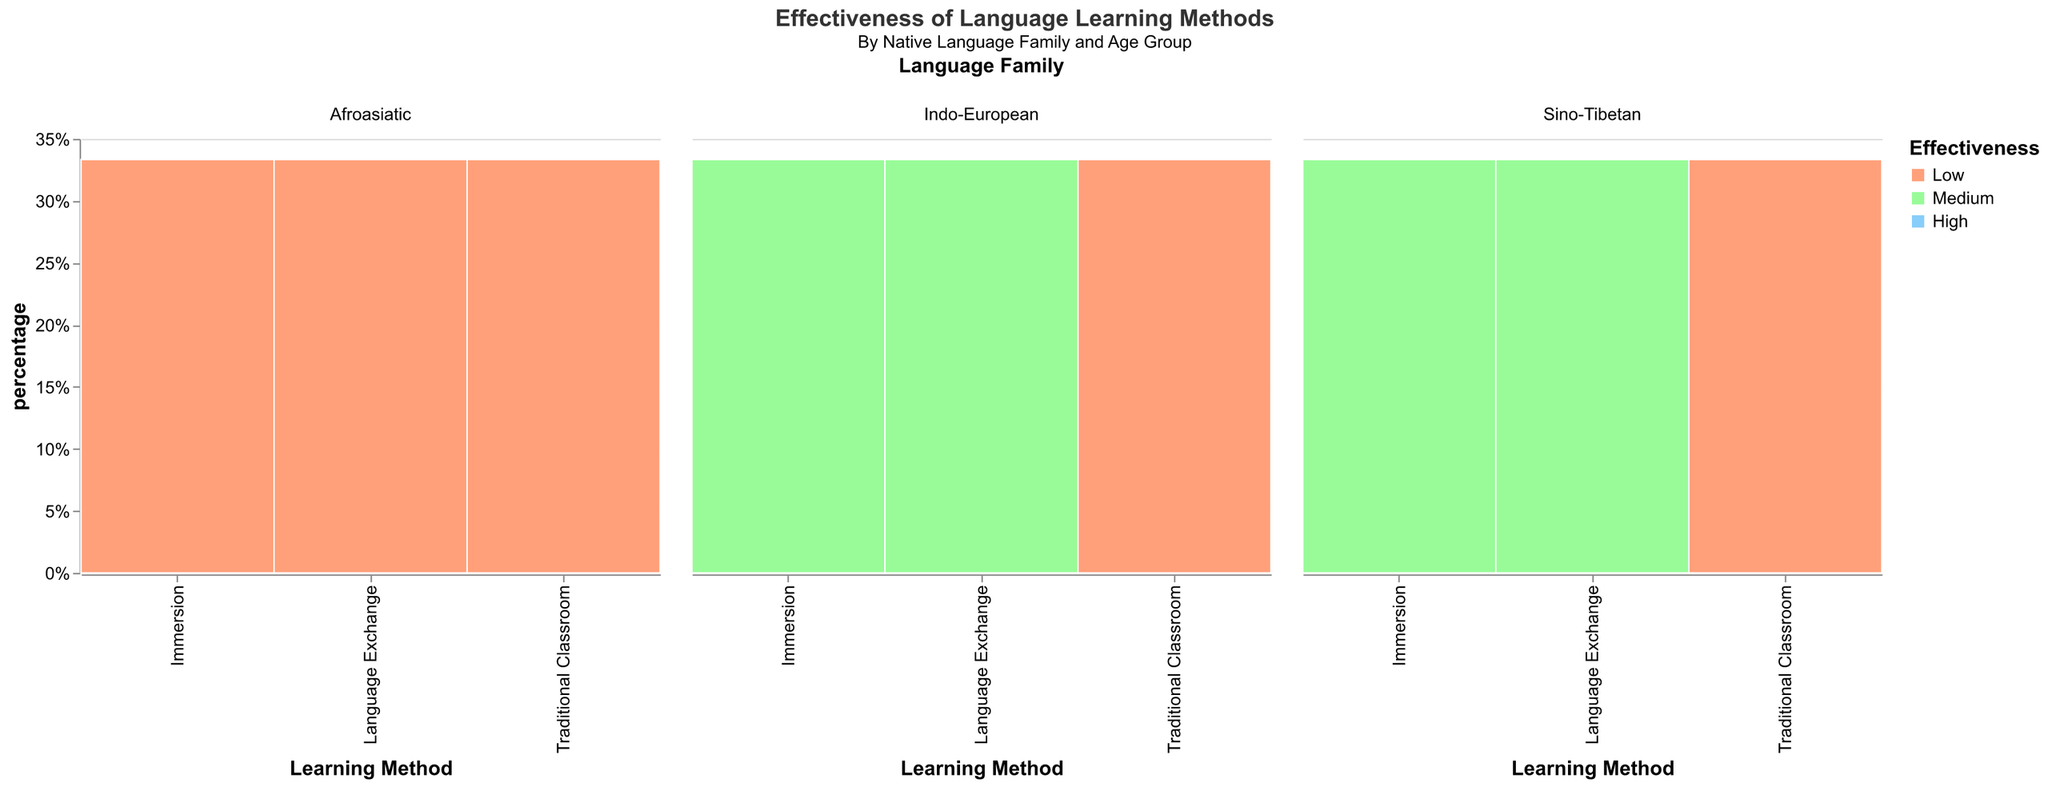What is the most effective language learning method for the 18-25 age group among Sino-Tibetan speakers? According to the mosaic plot, for Sino-Tibetan speakers in the 18-25 age group, the method with the highest effectiveness is highlighted in blue. This is associated with "High" effectiveness. The method that stands out is Immersion.
Answer: Immersion Which age group shows the lowest effectiveness for the Traditional Classroom method across all language families? By examining the mosaic plot for the Traditional Classroom method across Indo-European, Sino-Tibetan, and Afroasiatic families, it's clear that the 36+ age group consistently shows the lowest effectiveness with the color orange indicating "Low".
Answer: 36+ How does the effectiveness of Language Exchange compare between Afroasiatic students aged 18-25 and those aged 36+? For the 18-25 age group among Afroasiatic speakers, Language Exchange shows high effectiveness (blue). For the 36+ age group, it shows low effectiveness (orange). Thus, there is a marked decrease in effectiveness.
Answer: 18-25: High, 36+: Low What is the effectiveness of Immersion for Indo-European speakers aged 26-35? The plot shows the effectiveness for Indo-European speakers aged 26-35 using Immersion. The color representing Medium effectiveness (green) is observed for this combination.
Answer: Medium Which language family tends to find Traditional Classroom least effective, and in which age groups does this occur? By comparing the colors for Traditional Classroom across language families, Sino-Tibetan speakers show low effectiveness (orange) for both the 26-35 and 36+ age groups. This indicates a greater trend toward low effectiveness in these groups.
Answer: Sino-Tibetan, 26-35 and 36+ Among Indo-European speakers, which language learning method shows high effectiveness for the 26-35 age group? For Indo-European speakers aged 26-35, the mosaic plot shows "High" effectiveness (blue) for Language Exchange, indicating only this method is rated highly effective.
Answer: Language Exchange How does the effectiveness of Immersion vary across age groups for Afroasiatic speakers? For Afroasiatic speakers using Immersion, blue (High) is seen in the 18-25 age group, green (Medium) in the 26-35 age group, and orange (Low) in the 36+ age group. Thus, effectiveness decreases as age increases.
Answer: 18-25: High, 26-35: Medium, 36+: Low What percentage of Indo-European students aged 36+ finds the Traditional Classroom method effective? According to the tooltip data in the plot, for Indo-European speakers aged 36+, the Traditional Classroom method shows a 'Low' effectiveness. This indicates that the percentage is relatively small and the tooltip will likely show a low percentage value in line with the 'Low' effectiveness.
Answer: Low percentage Which combination of learning method and age group is most effective for Sino-Tibetan speakers? Upon examining the mosaic plot for the Sino-Tibetan family, the most effective combination is highlighted in blue (High), which occurs for the Immersion method within the 18-25 and 26-35 age groups.
Answer: Immersion, 18-25 and 26-35 Does the effectiveness of Language Exchange for Indo-European students change with age? If so, how? For Indo-European students, the mosaic plot shows "High" effectiveness (blue) for the 18-25 and 26-35 age groups, while it shows "Medium" effectiveness (green) for the 36+ age group. This suggests a decrease in effectiveness with age.
Answer: Yes, decreases from High to Medium in the 36+ group 